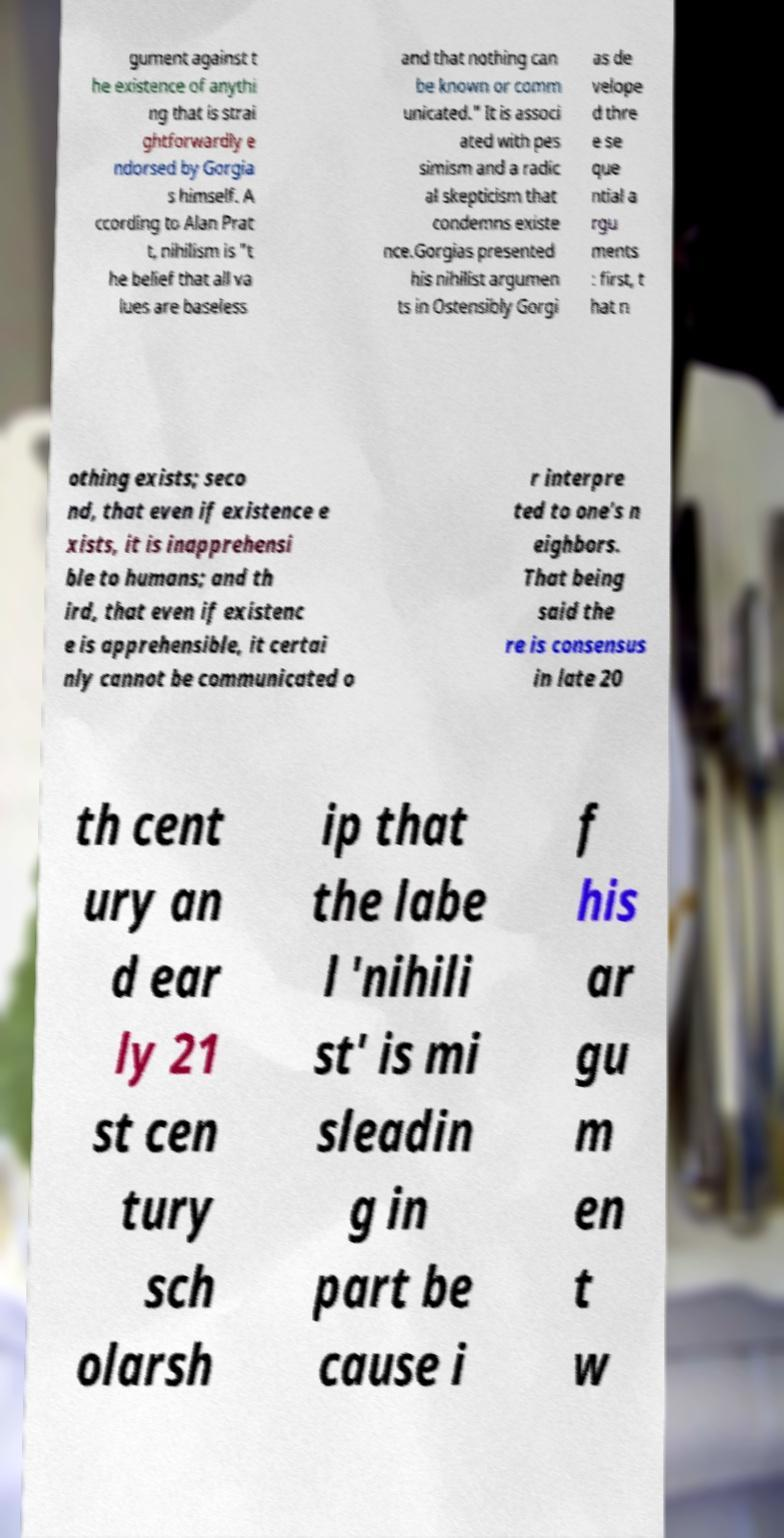Can you read and provide the text displayed in the image?This photo seems to have some interesting text. Can you extract and type it out for me? gument against t he existence of anythi ng that is strai ghtforwardly e ndorsed by Gorgia s himself. A ccording to Alan Prat t, nihilism is "t he belief that all va lues are baseless and that nothing can be known or comm unicated." It is associ ated with pes simism and a radic al skepticism that condemns existe nce.Gorgias presented his nihilist argumen ts in Ostensibly Gorgi as de velope d thre e se que ntial a rgu ments : first, t hat n othing exists; seco nd, that even if existence e xists, it is inapprehensi ble to humans; and th ird, that even if existenc e is apprehensible, it certai nly cannot be communicated o r interpre ted to one's n eighbors. That being said the re is consensus in late 20 th cent ury an d ear ly 21 st cen tury sch olarsh ip that the labe l 'nihili st' is mi sleadin g in part be cause i f his ar gu m en t w 